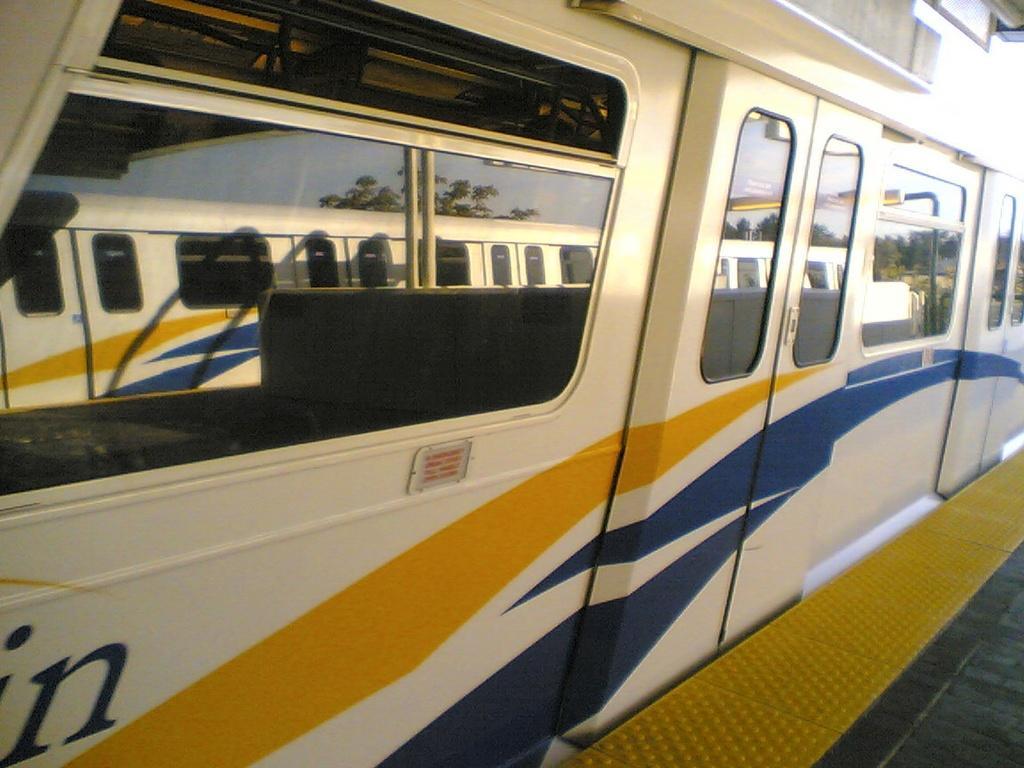Could you give a brief overview of what you see in this image? In this image I can see the platform which is yellow and black in color and a train which is black, yellow, blue and cream in color. I can see few windows of the train and on them I can see the reflection of few trees, another train and the sky. 